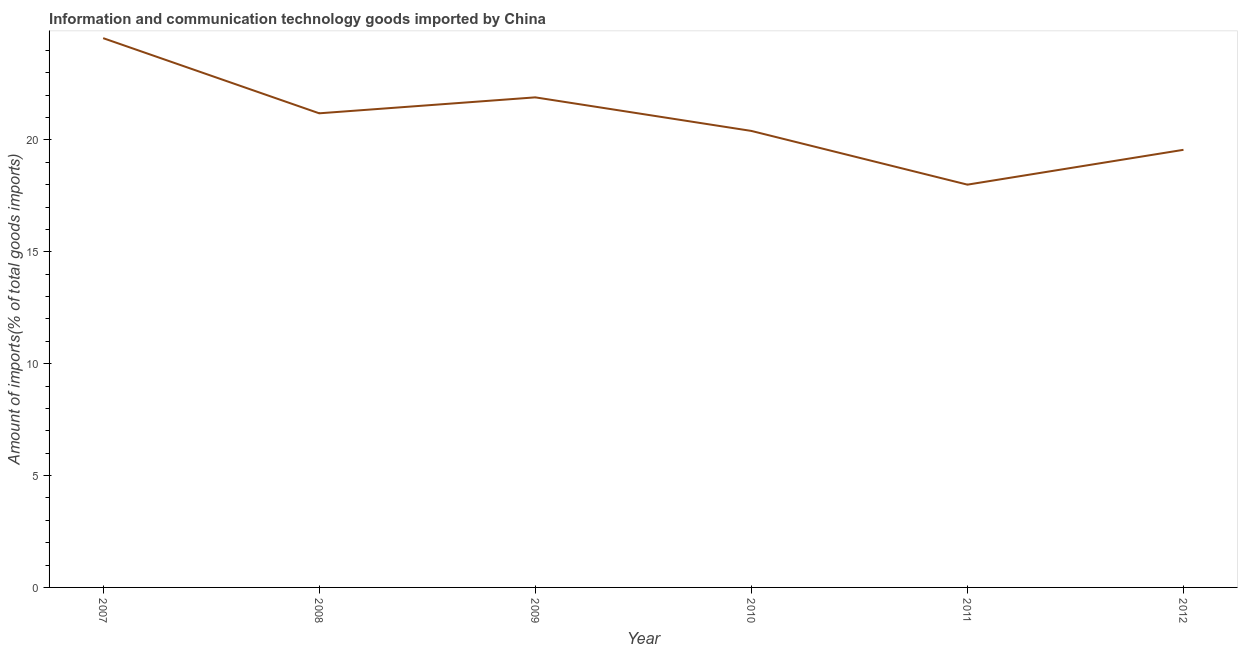What is the amount of ict goods imports in 2007?
Your answer should be compact. 24.55. Across all years, what is the maximum amount of ict goods imports?
Your answer should be compact. 24.55. Across all years, what is the minimum amount of ict goods imports?
Offer a very short reply. 18. In which year was the amount of ict goods imports minimum?
Make the answer very short. 2011. What is the sum of the amount of ict goods imports?
Your answer should be very brief. 125.59. What is the difference between the amount of ict goods imports in 2010 and 2012?
Offer a very short reply. 0.84. What is the average amount of ict goods imports per year?
Your answer should be compact. 20.93. What is the median amount of ict goods imports?
Your answer should be compact. 20.79. In how many years, is the amount of ict goods imports greater than 3 %?
Offer a very short reply. 6. Do a majority of the years between 2007 and 2008 (inclusive) have amount of ict goods imports greater than 16 %?
Keep it short and to the point. Yes. What is the ratio of the amount of ict goods imports in 2009 to that in 2011?
Ensure brevity in your answer.  1.22. Is the amount of ict goods imports in 2009 less than that in 2012?
Your response must be concise. No. What is the difference between the highest and the second highest amount of ict goods imports?
Offer a very short reply. 2.65. What is the difference between the highest and the lowest amount of ict goods imports?
Give a very brief answer. 6.55. Does the amount of ict goods imports monotonically increase over the years?
Your answer should be compact. No. How many years are there in the graph?
Your answer should be compact. 6. Does the graph contain any zero values?
Your response must be concise. No. What is the title of the graph?
Your answer should be compact. Information and communication technology goods imported by China. What is the label or title of the Y-axis?
Keep it short and to the point. Amount of imports(% of total goods imports). What is the Amount of imports(% of total goods imports) in 2007?
Keep it short and to the point. 24.55. What is the Amount of imports(% of total goods imports) of 2008?
Offer a terse response. 21.19. What is the Amount of imports(% of total goods imports) of 2009?
Ensure brevity in your answer.  21.9. What is the Amount of imports(% of total goods imports) in 2010?
Your answer should be very brief. 20.4. What is the Amount of imports(% of total goods imports) in 2011?
Offer a very short reply. 18. What is the Amount of imports(% of total goods imports) of 2012?
Offer a terse response. 19.56. What is the difference between the Amount of imports(% of total goods imports) in 2007 and 2008?
Give a very brief answer. 3.36. What is the difference between the Amount of imports(% of total goods imports) in 2007 and 2009?
Ensure brevity in your answer.  2.65. What is the difference between the Amount of imports(% of total goods imports) in 2007 and 2010?
Your answer should be compact. 4.15. What is the difference between the Amount of imports(% of total goods imports) in 2007 and 2011?
Your response must be concise. 6.55. What is the difference between the Amount of imports(% of total goods imports) in 2007 and 2012?
Your answer should be very brief. 4.99. What is the difference between the Amount of imports(% of total goods imports) in 2008 and 2009?
Provide a short and direct response. -0.71. What is the difference between the Amount of imports(% of total goods imports) in 2008 and 2010?
Make the answer very short. 0.79. What is the difference between the Amount of imports(% of total goods imports) in 2008 and 2011?
Your answer should be compact. 3.19. What is the difference between the Amount of imports(% of total goods imports) in 2008 and 2012?
Your response must be concise. 1.63. What is the difference between the Amount of imports(% of total goods imports) in 2009 and 2010?
Make the answer very short. 1.5. What is the difference between the Amount of imports(% of total goods imports) in 2009 and 2011?
Offer a terse response. 3.9. What is the difference between the Amount of imports(% of total goods imports) in 2009 and 2012?
Provide a succinct answer. 2.34. What is the difference between the Amount of imports(% of total goods imports) in 2010 and 2011?
Your answer should be compact. 2.4. What is the difference between the Amount of imports(% of total goods imports) in 2010 and 2012?
Keep it short and to the point. 0.84. What is the difference between the Amount of imports(% of total goods imports) in 2011 and 2012?
Ensure brevity in your answer.  -1.56. What is the ratio of the Amount of imports(% of total goods imports) in 2007 to that in 2008?
Give a very brief answer. 1.16. What is the ratio of the Amount of imports(% of total goods imports) in 2007 to that in 2009?
Provide a succinct answer. 1.12. What is the ratio of the Amount of imports(% of total goods imports) in 2007 to that in 2010?
Offer a very short reply. 1.2. What is the ratio of the Amount of imports(% of total goods imports) in 2007 to that in 2011?
Provide a succinct answer. 1.36. What is the ratio of the Amount of imports(% of total goods imports) in 2007 to that in 2012?
Offer a terse response. 1.25. What is the ratio of the Amount of imports(% of total goods imports) in 2008 to that in 2009?
Ensure brevity in your answer.  0.97. What is the ratio of the Amount of imports(% of total goods imports) in 2008 to that in 2010?
Provide a succinct answer. 1.04. What is the ratio of the Amount of imports(% of total goods imports) in 2008 to that in 2011?
Your answer should be compact. 1.18. What is the ratio of the Amount of imports(% of total goods imports) in 2008 to that in 2012?
Provide a succinct answer. 1.08. What is the ratio of the Amount of imports(% of total goods imports) in 2009 to that in 2010?
Offer a terse response. 1.07. What is the ratio of the Amount of imports(% of total goods imports) in 2009 to that in 2011?
Offer a very short reply. 1.22. What is the ratio of the Amount of imports(% of total goods imports) in 2009 to that in 2012?
Your response must be concise. 1.12. What is the ratio of the Amount of imports(% of total goods imports) in 2010 to that in 2011?
Give a very brief answer. 1.13. What is the ratio of the Amount of imports(% of total goods imports) in 2010 to that in 2012?
Provide a short and direct response. 1.04. 